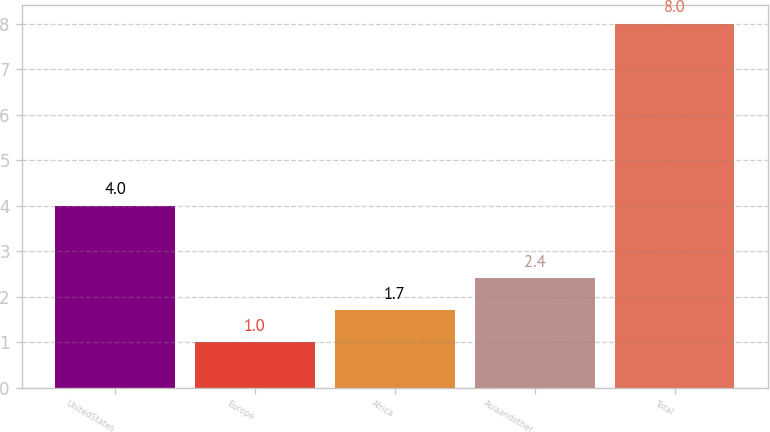Convert chart to OTSL. <chart><loc_0><loc_0><loc_500><loc_500><bar_chart><fcel>UnitedStates<fcel>Europe<fcel>Africa<fcel>Asiaandother<fcel>Total<nl><fcel>4<fcel>1<fcel>1.7<fcel>2.4<fcel>8<nl></chart> 